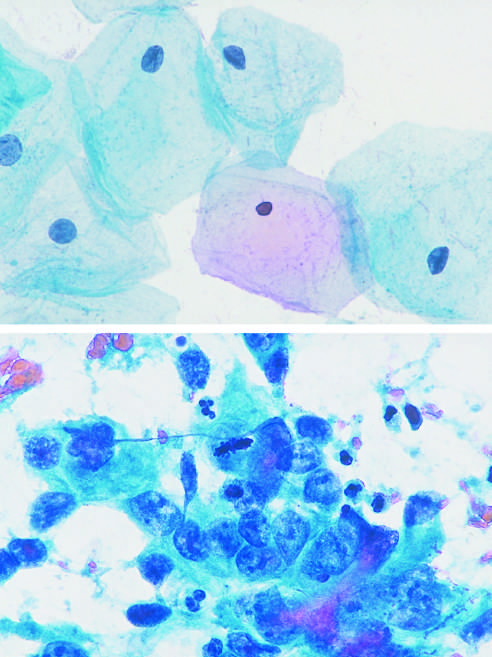re two small pulmonary arterioles typical?
Answer the question using a single word or phrase. No 